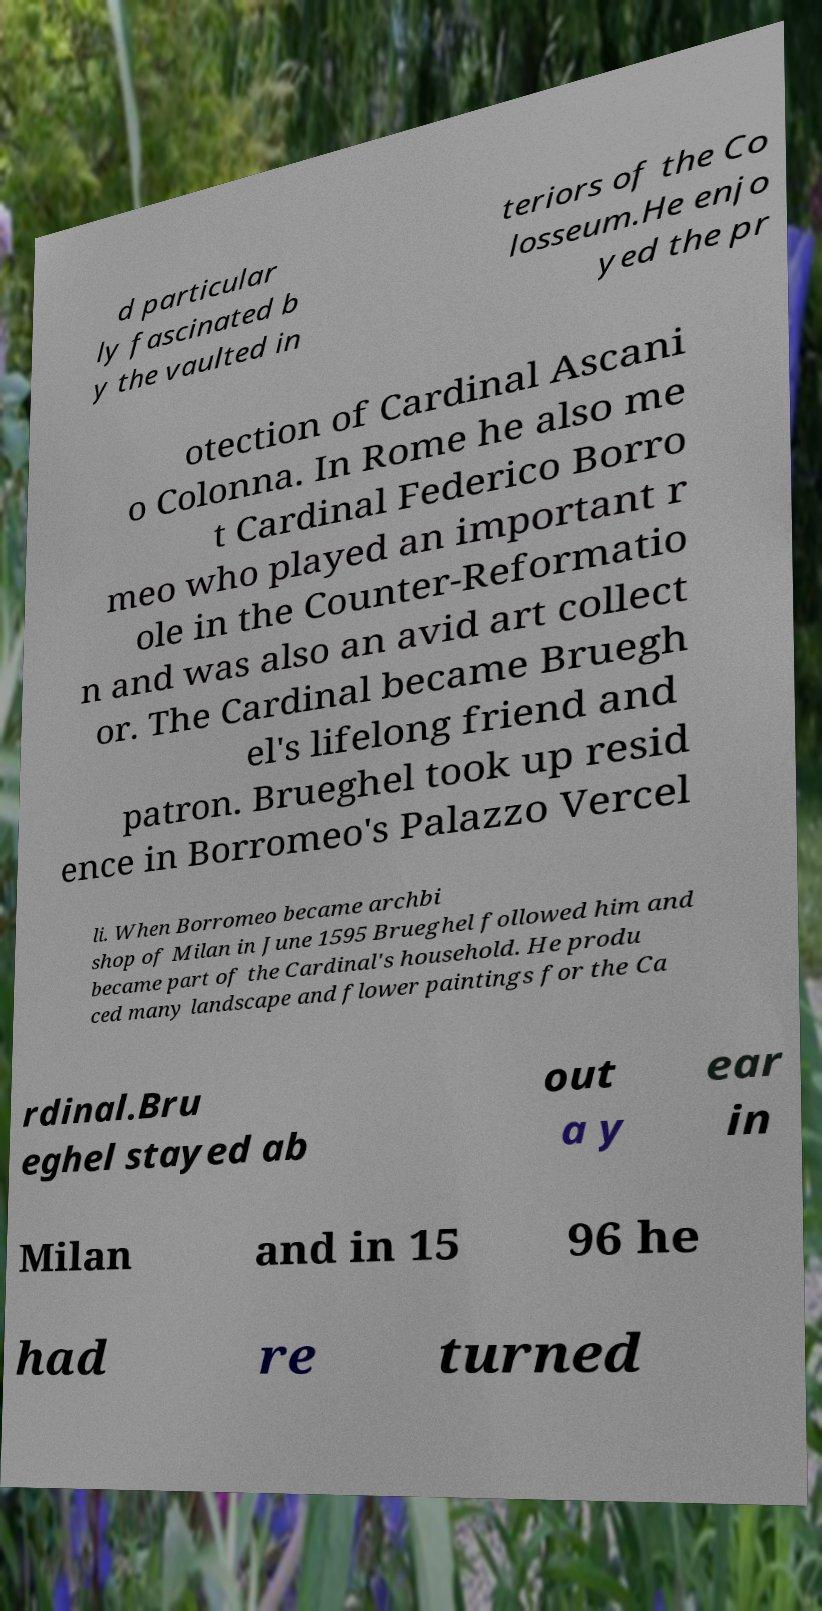For documentation purposes, I need the text within this image transcribed. Could you provide that? d particular ly fascinated b y the vaulted in teriors of the Co losseum.He enjo yed the pr otection of Cardinal Ascani o Colonna. In Rome he also me t Cardinal Federico Borro meo who played an important r ole in the Counter-Reformatio n and was also an avid art collect or. The Cardinal became Bruegh el's lifelong friend and patron. Brueghel took up resid ence in Borromeo's Palazzo Vercel li. When Borromeo became archbi shop of Milan in June 1595 Brueghel followed him and became part of the Cardinal's household. He produ ced many landscape and flower paintings for the Ca rdinal.Bru eghel stayed ab out a y ear in Milan and in 15 96 he had re turned 